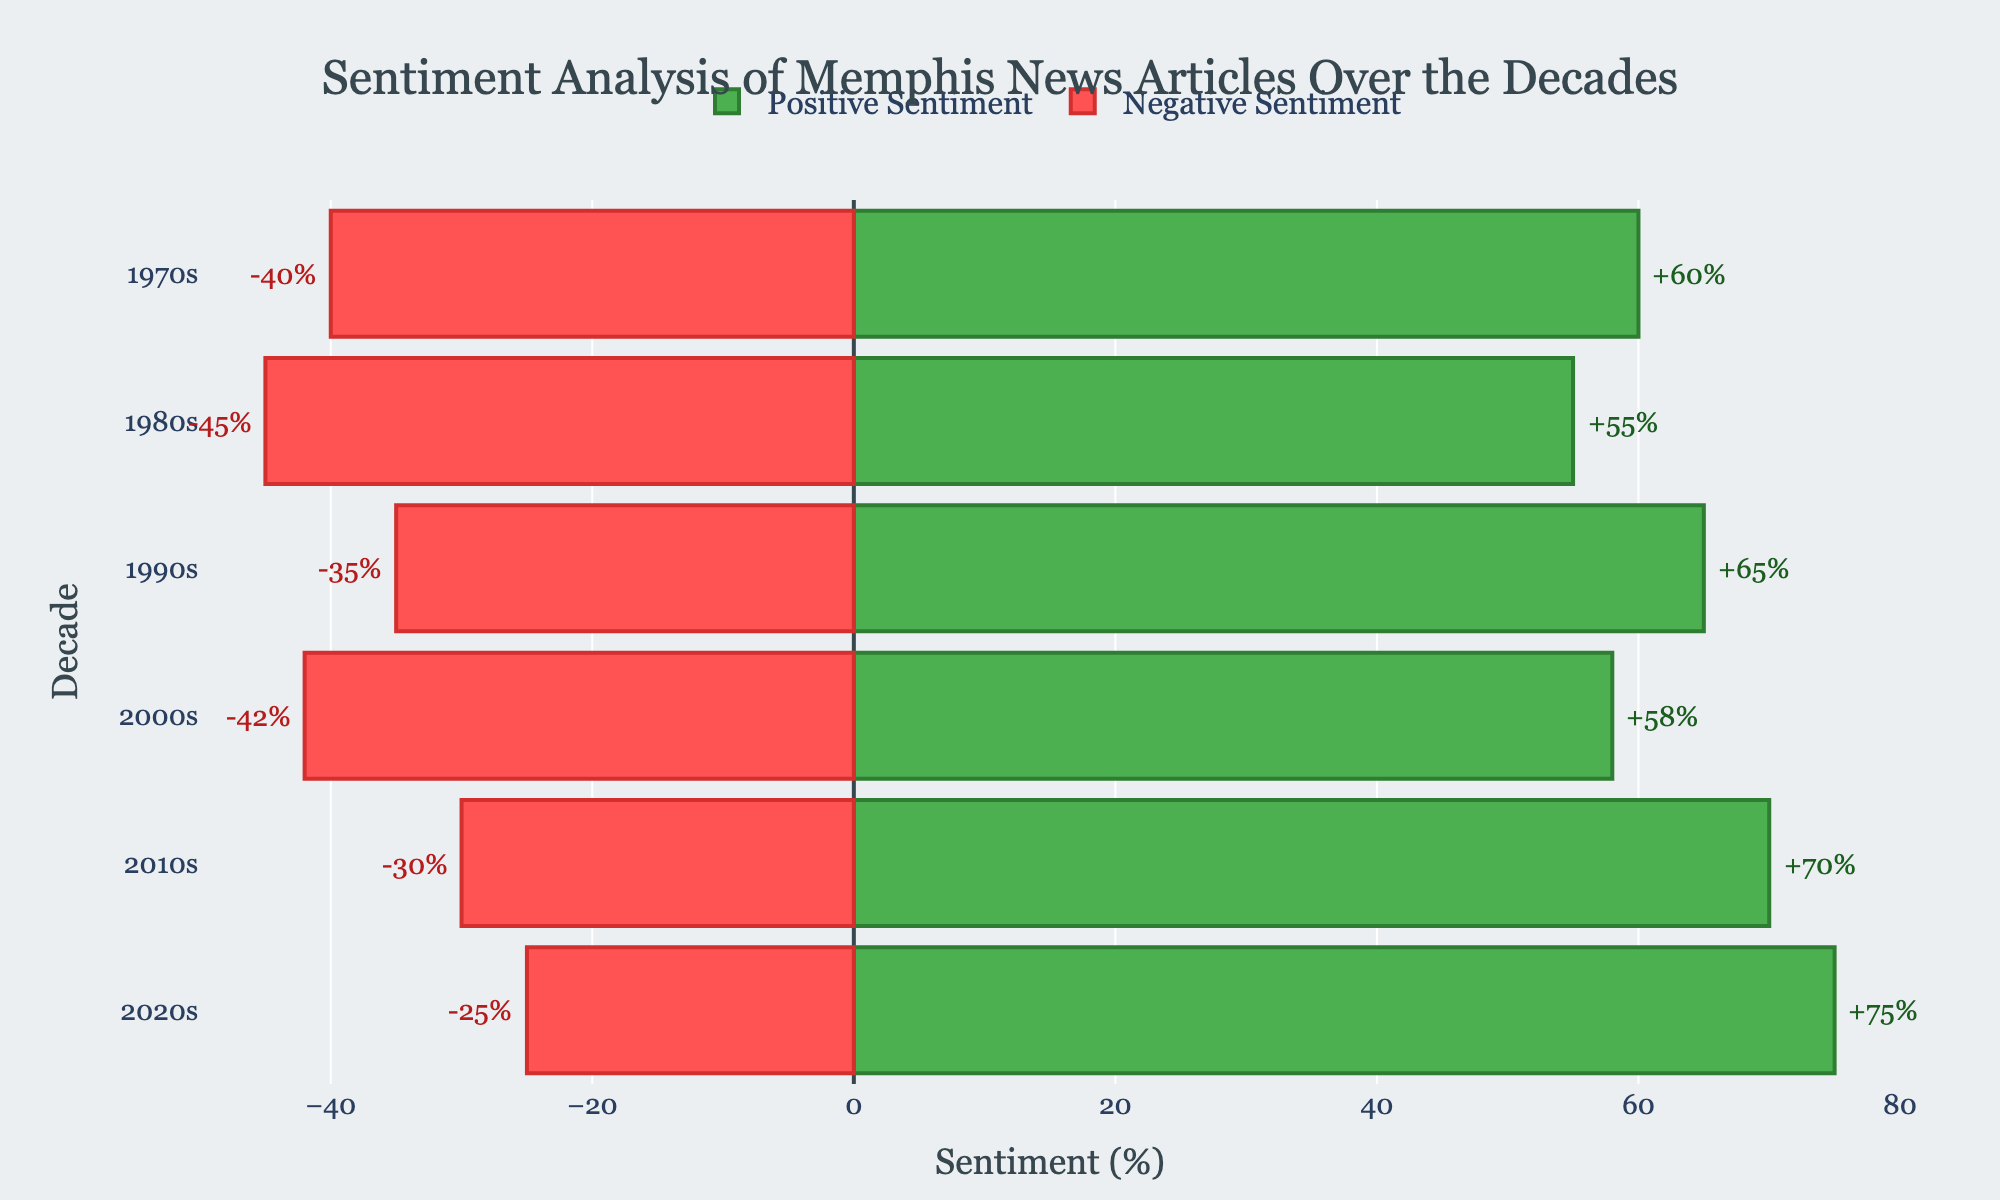What decade has the highest positive sentiment in Memphis news articles? First, identify the highest value among all positive sentiment bars. The highest positive sentiment (75%) occurs in the 2020s.
Answer: 2020s What is the overall trend in negative sentiment from the 1970s to the 2020s? Observe the negative sentiment values across the decades. They start at 40% in the 1970s, then gradually decrease to 25% in the 2020s. This shows a declining trend in negative sentiment.
Answer: Declining What is the difference in positive sentiment between the 2000s and 2010s? Find the positive sentiments for both decades: 58% (2000s) and 70% (2010s). Subtract the former from the latter: 70% - 58% = 12%.
Answer: 12% Which decade shows the smallest gap between positive and negative sentiment? Calculate the difference between positive and negative sentiments for each decade. The 1980s have the smallest gap: 55% positive - 45% negative = 10%.
Answer: 1980s How many decades have a positive sentiment greater than 60%? Count the decades with positive sentiments exceeding 60%. The 1970s, 1990s, 2010s, and 2020s, making a total of four decades.
Answer: 4 In which decades did negative sentiment exceed 35%? Identify negative sentiments above 35%. The 1970s, 1980s, and 2000s exceed this threshold.
Answer: 1970s, 1980s, 2000s What is the range of positive sentiment values across all decades? Determine the smallest and largest positive sentiment values: 55% (1980s) and 75% (2020s). The range is 75% - 55% = 20%.
Answer: 20% How does the positive sentiment of the 1990s compare to that of the 1980s? Compare the values directly. The 1990s have a positive sentiment of 65%, and the 1980s have 55%. The 1990s have a higher positive sentiment by 10%.
Answer: 10% higher What is the combined percentage of positive and negative sentiments in the 1970s? Sum the positive sentiment (60%) and negative sentiment (40%) for the 1970s: 60% + 40% = 100%.
Answer: 100% Do the 2010s have higher positive sentiment than the 2000s, and by what percentage? Compare the positive sentiments: 70% (2010s) and 58% (2000s). The increase is 70% - 58% = 12%.
Answer: Yes, by 12% 